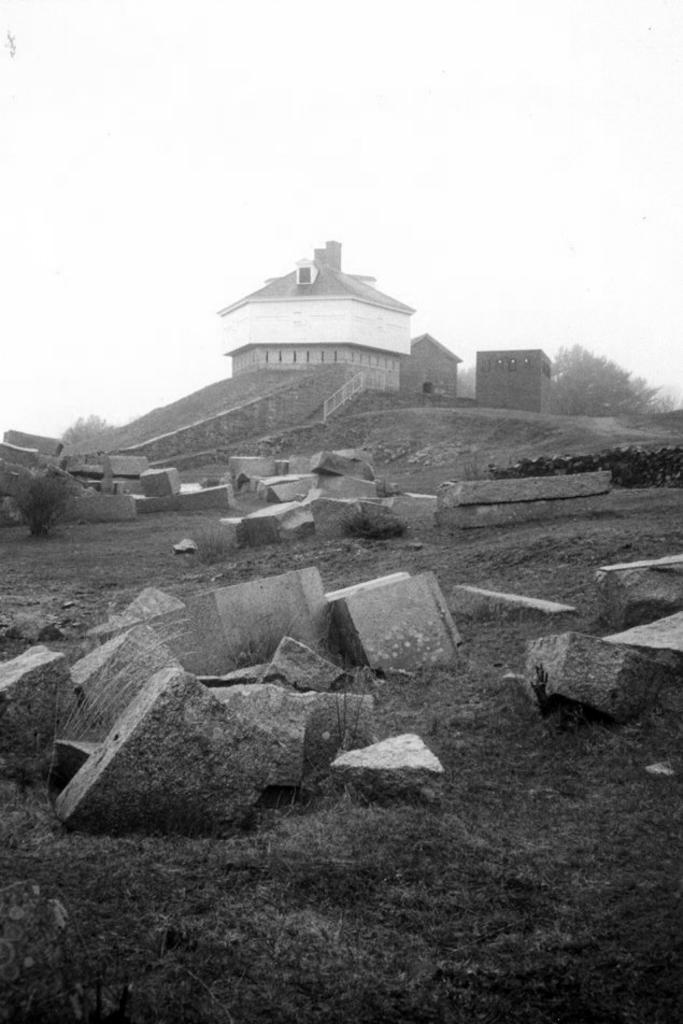How would you summarize this image in a sentence or two? In this picture we can see a few plants, grass and stones on the ground. We can see houses, other objects and the sky. 